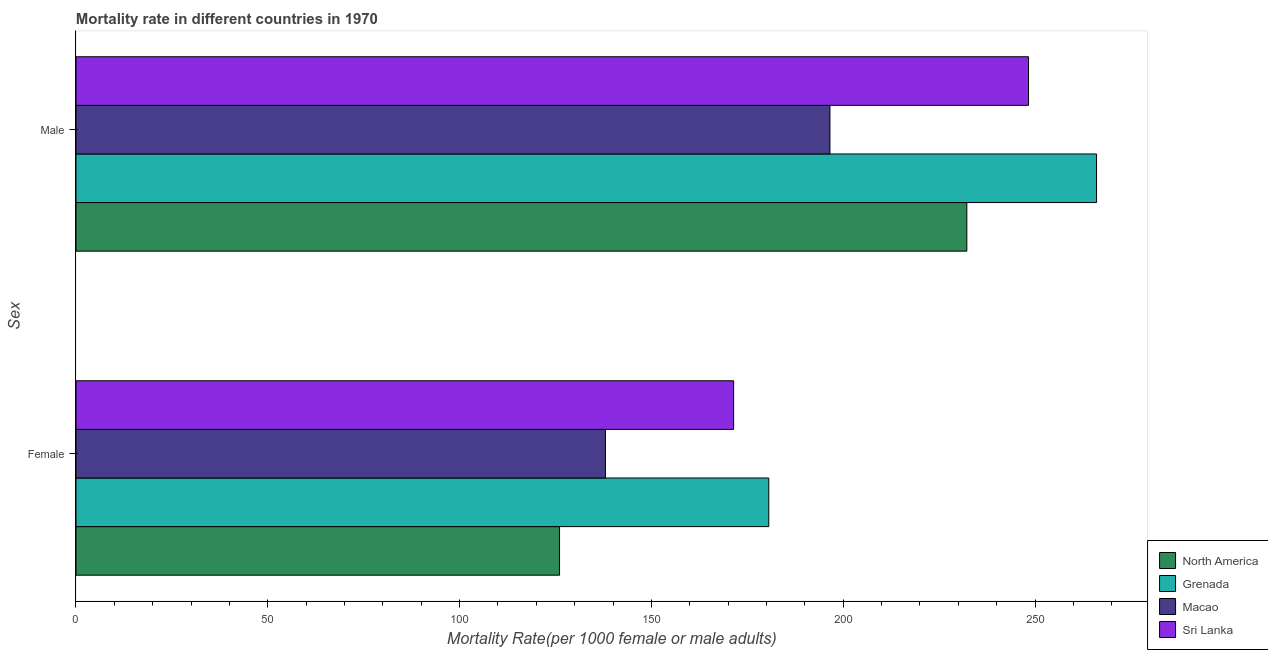How many different coloured bars are there?
Offer a terse response. 4. How many groups of bars are there?
Keep it short and to the point. 2. Are the number of bars per tick equal to the number of legend labels?
Keep it short and to the point. Yes. Are the number of bars on each tick of the Y-axis equal?
Offer a very short reply. Yes. How many bars are there on the 1st tick from the top?
Ensure brevity in your answer.  4. How many bars are there on the 2nd tick from the bottom?
Your answer should be compact. 4. What is the label of the 1st group of bars from the top?
Provide a succinct answer. Male. What is the male mortality rate in Macao?
Ensure brevity in your answer.  196.54. Across all countries, what is the maximum male mortality rate?
Your answer should be very brief. 266.02. Across all countries, what is the minimum male mortality rate?
Offer a very short reply. 196.54. In which country was the male mortality rate maximum?
Provide a succinct answer. Grenada. In which country was the male mortality rate minimum?
Your answer should be compact. Macao. What is the total male mortality rate in the graph?
Provide a succinct answer. 943.07. What is the difference between the male mortality rate in Sri Lanka and that in North America?
Offer a terse response. 16.08. What is the difference between the male mortality rate in Grenada and the female mortality rate in Sri Lanka?
Offer a very short reply. 94.6. What is the average male mortality rate per country?
Make the answer very short. 235.77. What is the difference between the female mortality rate and male mortality rate in Grenada?
Ensure brevity in your answer.  -85.43. What is the ratio of the male mortality rate in North America to that in Macao?
Ensure brevity in your answer.  1.18. In how many countries, is the male mortality rate greater than the average male mortality rate taken over all countries?
Your answer should be very brief. 2. What does the 3rd bar from the top in Female represents?
Your answer should be very brief. Grenada. What does the 4th bar from the bottom in Female represents?
Keep it short and to the point. Sri Lanka. How many countries are there in the graph?
Your response must be concise. 4. Are the values on the major ticks of X-axis written in scientific E-notation?
Ensure brevity in your answer.  No. Does the graph contain any zero values?
Offer a terse response. No. Does the graph contain grids?
Offer a very short reply. No. How are the legend labels stacked?
Keep it short and to the point. Vertical. What is the title of the graph?
Provide a succinct answer. Mortality rate in different countries in 1970. What is the label or title of the X-axis?
Offer a terse response. Mortality Rate(per 1000 female or male adults). What is the label or title of the Y-axis?
Your answer should be compact. Sex. What is the Mortality Rate(per 1000 female or male adults) in North America in Female?
Your answer should be compact. 126.05. What is the Mortality Rate(per 1000 female or male adults) of Grenada in Female?
Your answer should be compact. 180.59. What is the Mortality Rate(per 1000 female or male adults) in Macao in Female?
Offer a terse response. 138.02. What is the Mortality Rate(per 1000 female or male adults) of Sri Lanka in Female?
Offer a terse response. 171.43. What is the Mortality Rate(per 1000 female or male adults) in North America in Male?
Give a very brief answer. 232.21. What is the Mortality Rate(per 1000 female or male adults) of Grenada in Male?
Provide a short and direct response. 266.02. What is the Mortality Rate(per 1000 female or male adults) in Macao in Male?
Provide a short and direct response. 196.54. What is the Mortality Rate(per 1000 female or male adults) of Sri Lanka in Male?
Offer a very short reply. 248.3. Across all Sex, what is the maximum Mortality Rate(per 1000 female or male adults) in North America?
Your answer should be compact. 232.21. Across all Sex, what is the maximum Mortality Rate(per 1000 female or male adults) of Grenada?
Give a very brief answer. 266.02. Across all Sex, what is the maximum Mortality Rate(per 1000 female or male adults) of Macao?
Ensure brevity in your answer.  196.54. Across all Sex, what is the maximum Mortality Rate(per 1000 female or male adults) in Sri Lanka?
Your answer should be very brief. 248.3. Across all Sex, what is the minimum Mortality Rate(per 1000 female or male adults) of North America?
Provide a short and direct response. 126.05. Across all Sex, what is the minimum Mortality Rate(per 1000 female or male adults) in Grenada?
Make the answer very short. 180.59. Across all Sex, what is the minimum Mortality Rate(per 1000 female or male adults) of Macao?
Your response must be concise. 138.02. Across all Sex, what is the minimum Mortality Rate(per 1000 female or male adults) of Sri Lanka?
Offer a very short reply. 171.43. What is the total Mortality Rate(per 1000 female or male adults) of North America in the graph?
Offer a terse response. 358.27. What is the total Mortality Rate(per 1000 female or male adults) of Grenada in the graph?
Give a very brief answer. 446.62. What is the total Mortality Rate(per 1000 female or male adults) of Macao in the graph?
Make the answer very short. 334.55. What is the total Mortality Rate(per 1000 female or male adults) in Sri Lanka in the graph?
Make the answer very short. 419.72. What is the difference between the Mortality Rate(per 1000 female or male adults) of North America in Female and that in Male?
Offer a terse response. -106.16. What is the difference between the Mortality Rate(per 1000 female or male adults) in Grenada in Female and that in Male?
Your response must be concise. -85.43. What is the difference between the Mortality Rate(per 1000 female or male adults) in Macao in Female and that in Male?
Provide a succinct answer. -58.52. What is the difference between the Mortality Rate(per 1000 female or male adults) in Sri Lanka in Female and that in Male?
Offer a very short reply. -76.87. What is the difference between the Mortality Rate(per 1000 female or male adults) in North America in Female and the Mortality Rate(per 1000 female or male adults) in Grenada in Male?
Your answer should be very brief. -139.97. What is the difference between the Mortality Rate(per 1000 female or male adults) in North America in Female and the Mortality Rate(per 1000 female or male adults) in Macao in Male?
Give a very brief answer. -70.48. What is the difference between the Mortality Rate(per 1000 female or male adults) in North America in Female and the Mortality Rate(per 1000 female or male adults) in Sri Lanka in Male?
Your answer should be very brief. -122.24. What is the difference between the Mortality Rate(per 1000 female or male adults) of Grenada in Female and the Mortality Rate(per 1000 female or male adults) of Macao in Male?
Provide a short and direct response. -15.95. What is the difference between the Mortality Rate(per 1000 female or male adults) in Grenada in Female and the Mortality Rate(per 1000 female or male adults) in Sri Lanka in Male?
Provide a short and direct response. -67.7. What is the difference between the Mortality Rate(per 1000 female or male adults) in Macao in Female and the Mortality Rate(per 1000 female or male adults) in Sri Lanka in Male?
Ensure brevity in your answer.  -110.28. What is the average Mortality Rate(per 1000 female or male adults) of North America per Sex?
Keep it short and to the point. 179.13. What is the average Mortality Rate(per 1000 female or male adults) of Grenada per Sex?
Give a very brief answer. 223.31. What is the average Mortality Rate(per 1000 female or male adults) of Macao per Sex?
Your answer should be compact. 167.28. What is the average Mortality Rate(per 1000 female or male adults) in Sri Lanka per Sex?
Offer a terse response. 209.86. What is the difference between the Mortality Rate(per 1000 female or male adults) in North America and Mortality Rate(per 1000 female or male adults) in Grenada in Female?
Keep it short and to the point. -54.54. What is the difference between the Mortality Rate(per 1000 female or male adults) of North America and Mortality Rate(per 1000 female or male adults) of Macao in Female?
Give a very brief answer. -11.96. What is the difference between the Mortality Rate(per 1000 female or male adults) in North America and Mortality Rate(per 1000 female or male adults) in Sri Lanka in Female?
Your response must be concise. -45.37. What is the difference between the Mortality Rate(per 1000 female or male adults) in Grenada and Mortality Rate(per 1000 female or male adults) in Macao in Female?
Provide a short and direct response. 42.58. What is the difference between the Mortality Rate(per 1000 female or male adults) in Grenada and Mortality Rate(per 1000 female or male adults) in Sri Lanka in Female?
Provide a succinct answer. 9.17. What is the difference between the Mortality Rate(per 1000 female or male adults) of Macao and Mortality Rate(per 1000 female or male adults) of Sri Lanka in Female?
Provide a short and direct response. -33.41. What is the difference between the Mortality Rate(per 1000 female or male adults) in North America and Mortality Rate(per 1000 female or male adults) in Grenada in Male?
Offer a very short reply. -33.81. What is the difference between the Mortality Rate(per 1000 female or male adults) of North America and Mortality Rate(per 1000 female or male adults) of Macao in Male?
Your answer should be very brief. 35.68. What is the difference between the Mortality Rate(per 1000 female or male adults) of North America and Mortality Rate(per 1000 female or male adults) of Sri Lanka in Male?
Make the answer very short. -16.08. What is the difference between the Mortality Rate(per 1000 female or male adults) in Grenada and Mortality Rate(per 1000 female or male adults) in Macao in Male?
Make the answer very short. 69.49. What is the difference between the Mortality Rate(per 1000 female or male adults) of Grenada and Mortality Rate(per 1000 female or male adults) of Sri Lanka in Male?
Offer a terse response. 17.73. What is the difference between the Mortality Rate(per 1000 female or male adults) in Macao and Mortality Rate(per 1000 female or male adults) in Sri Lanka in Male?
Keep it short and to the point. -51.76. What is the ratio of the Mortality Rate(per 1000 female or male adults) of North America in Female to that in Male?
Make the answer very short. 0.54. What is the ratio of the Mortality Rate(per 1000 female or male adults) in Grenada in Female to that in Male?
Keep it short and to the point. 0.68. What is the ratio of the Mortality Rate(per 1000 female or male adults) of Macao in Female to that in Male?
Your response must be concise. 0.7. What is the ratio of the Mortality Rate(per 1000 female or male adults) in Sri Lanka in Female to that in Male?
Provide a succinct answer. 0.69. What is the difference between the highest and the second highest Mortality Rate(per 1000 female or male adults) in North America?
Give a very brief answer. 106.16. What is the difference between the highest and the second highest Mortality Rate(per 1000 female or male adults) of Grenada?
Provide a succinct answer. 85.43. What is the difference between the highest and the second highest Mortality Rate(per 1000 female or male adults) of Macao?
Your response must be concise. 58.52. What is the difference between the highest and the second highest Mortality Rate(per 1000 female or male adults) in Sri Lanka?
Keep it short and to the point. 76.87. What is the difference between the highest and the lowest Mortality Rate(per 1000 female or male adults) in North America?
Make the answer very short. 106.16. What is the difference between the highest and the lowest Mortality Rate(per 1000 female or male adults) in Grenada?
Your answer should be very brief. 85.43. What is the difference between the highest and the lowest Mortality Rate(per 1000 female or male adults) in Macao?
Ensure brevity in your answer.  58.52. What is the difference between the highest and the lowest Mortality Rate(per 1000 female or male adults) in Sri Lanka?
Provide a succinct answer. 76.87. 